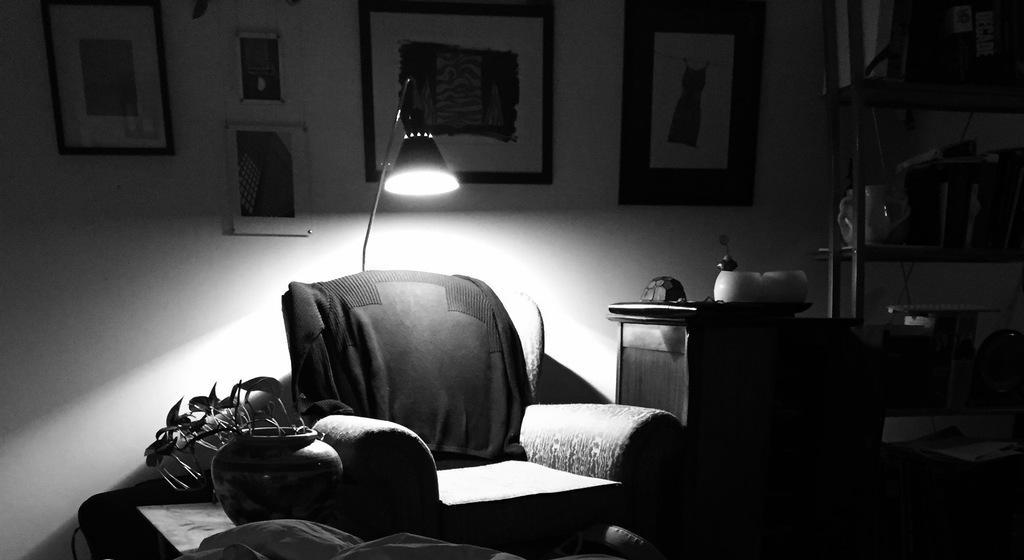How would you summarize this image in a sentence or two? In this picture there is a sofa in the middle of the room. Beside there is a wooden table. Behind there is a table light. In the background we can see a wall with many hanging photo frames. 